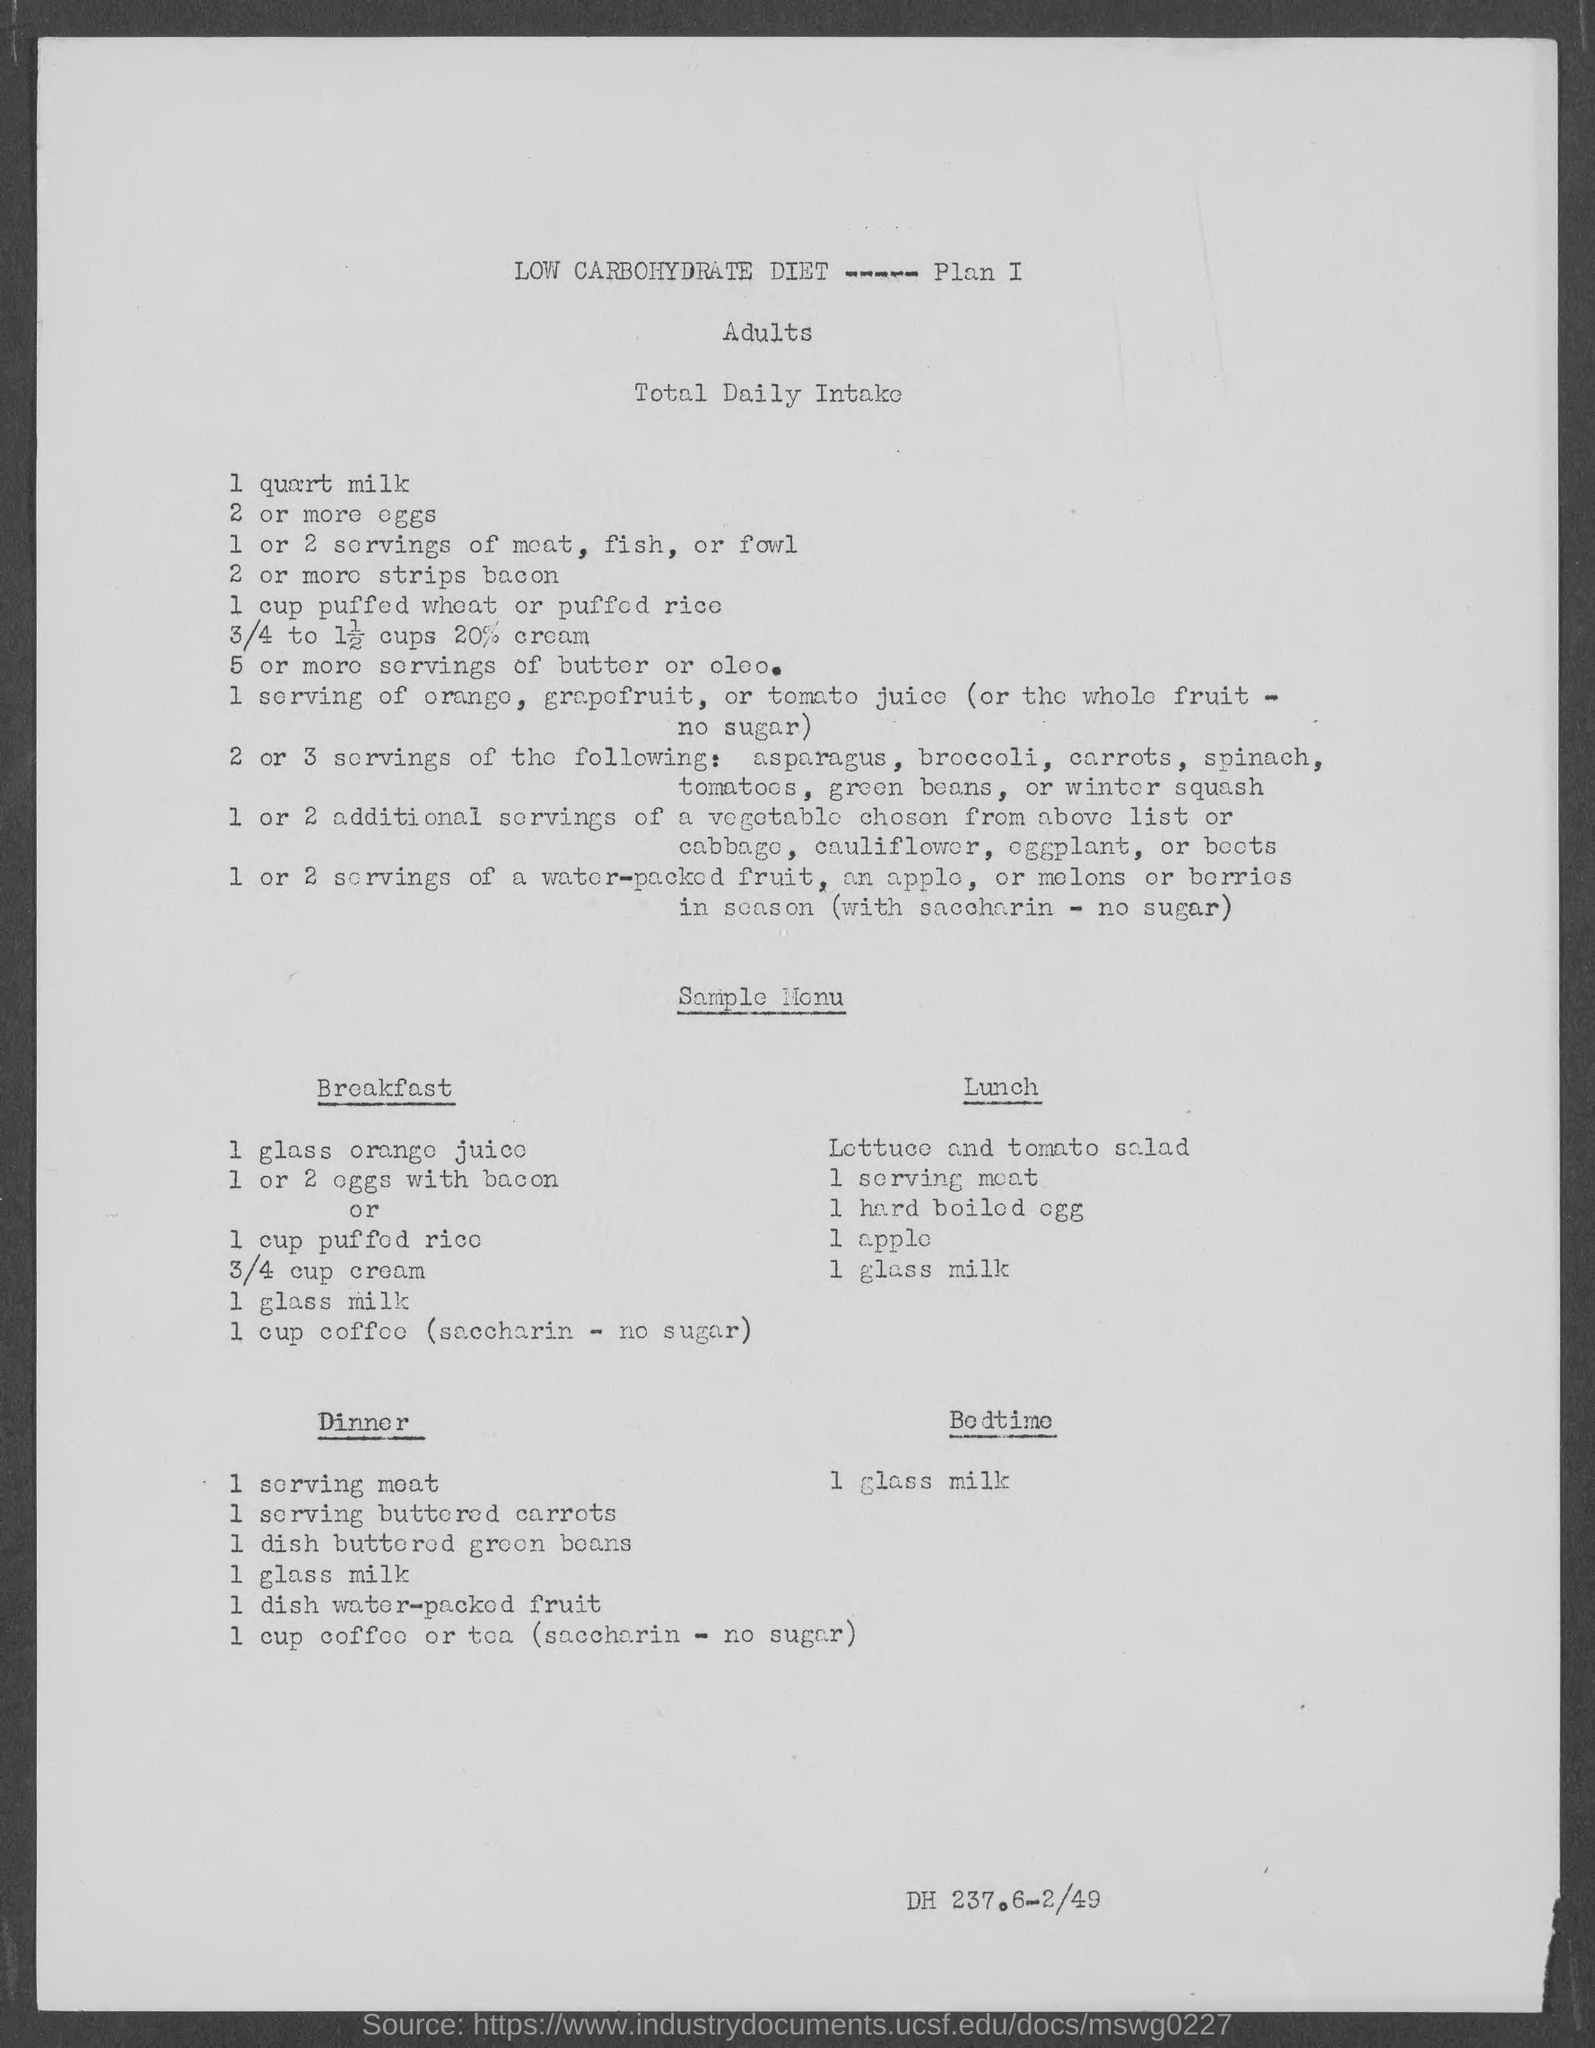What is the first item for Breakfast according to the diet plan?
Your answer should be very brief. 1 glass orange juice. What is the second item for Breakfast according to the diet plan?
Your answer should be compact. 1 or 2 eggs with bacon or 1 cup puffed rice. What is the first item for Lunch according to the diet plan?
Your response must be concise. Lettuce and tomato salad. What is the Bedtime food?
Offer a very short reply. 1 glass milk. Who's diet plan is given here ?
Offer a terse response. Adults. What is the third item for Lunch according to the diet plan?
Your answer should be very brief. 1 hard boiled egg. What is the fourth item for Lunch according to the diet plan?
Give a very brief answer. 1 apple. What is the fifth item for Lunch according to the diet plan?
Make the answer very short. 1 glass milk. 